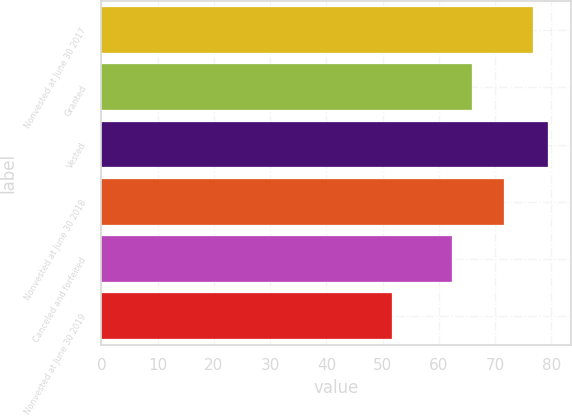Convert chart. <chart><loc_0><loc_0><loc_500><loc_500><bar_chart><fcel>Nonvested at June 30 2017<fcel>Granted<fcel>Vested<fcel>Nonvested at June 30 2018<fcel>Canceled and forfeited<fcel>Nonvested at June 30 2019<nl><fcel>76.72<fcel>65.97<fcel>79.45<fcel>71.58<fcel>62.32<fcel>51.65<nl></chart> 